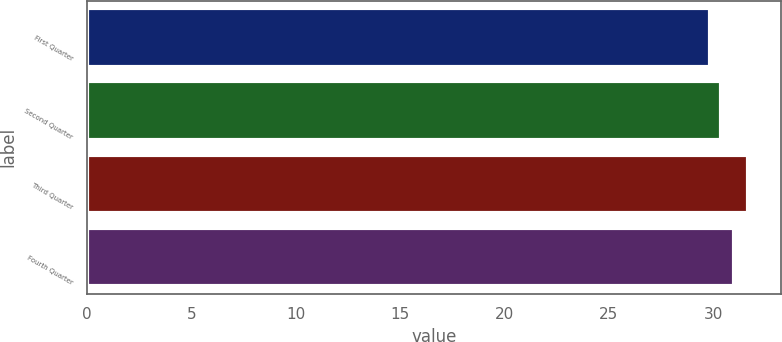<chart> <loc_0><loc_0><loc_500><loc_500><bar_chart><fcel>First Quarter<fcel>Second Quarter<fcel>Third Quarter<fcel>Fourth Quarter<nl><fcel>29.86<fcel>30.36<fcel>31.67<fcel>30.99<nl></chart> 